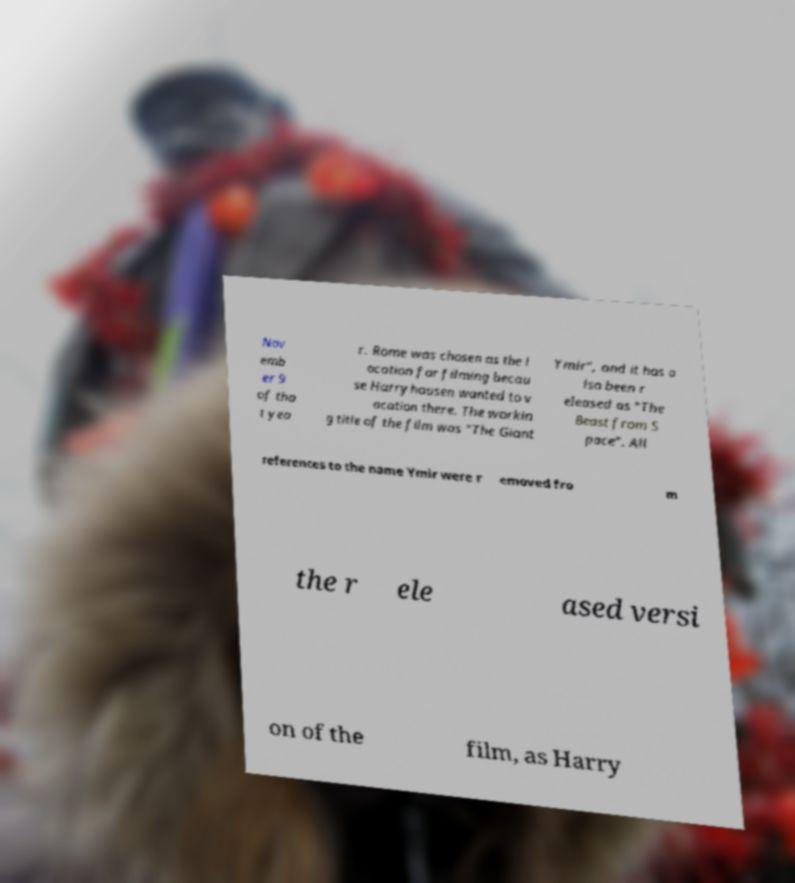I need the written content from this picture converted into text. Can you do that? Nov emb er 9 of tha t yea r. Rome was chosen as the l ocation for filming becau se Harryhausen wanted to v acation there. The workin g title of the film was "The Giant Ymir", and it has a lso been r eleased as "The Beast from S pace". All references to the name Ymir were r emoved fro m the r ele ased versi on of the film, as Harry 